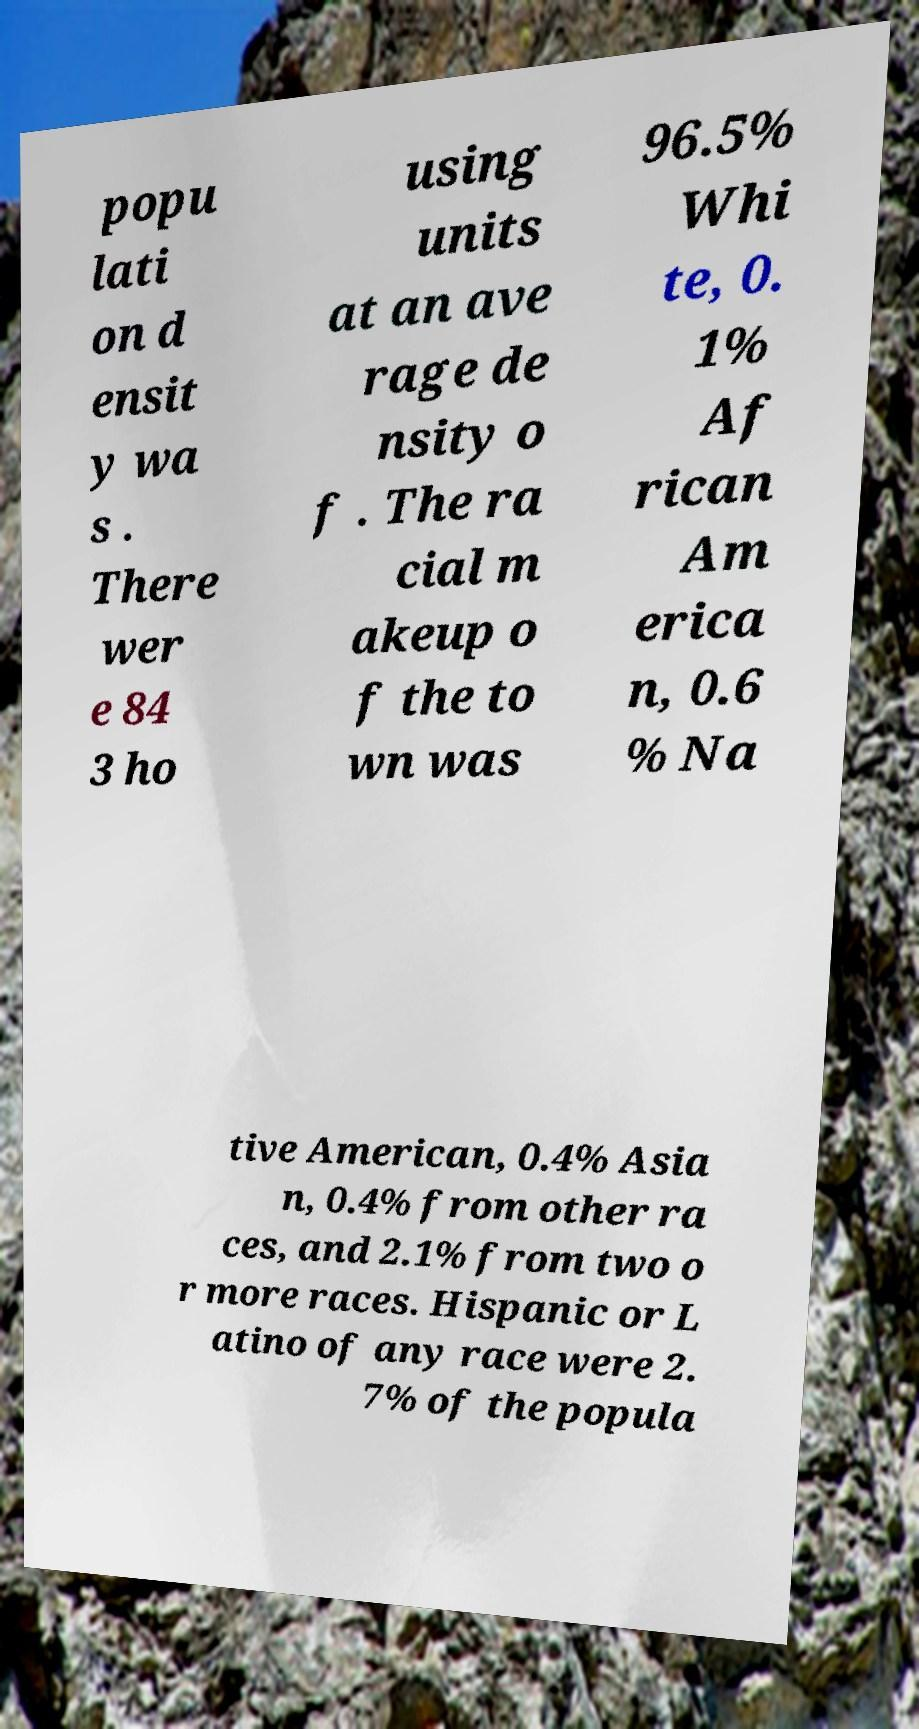There's text embedded in this image that I need extracted. Can you transcribe it verbatim? popu lati on d ensit y wa s . There wer e 84 3 ho using units at an ave rage de nsity o f . The ra cial m akeup o f the to wn was 96.5% Whi te, 0. 1% Af rican Am erica n, 0.6 % Na tive American, 0.4% Asia n, 0.4% from other ra ces, and 2.1% from two o r more races. Hispanic or L atino of any race were 2. 7% of the popula 